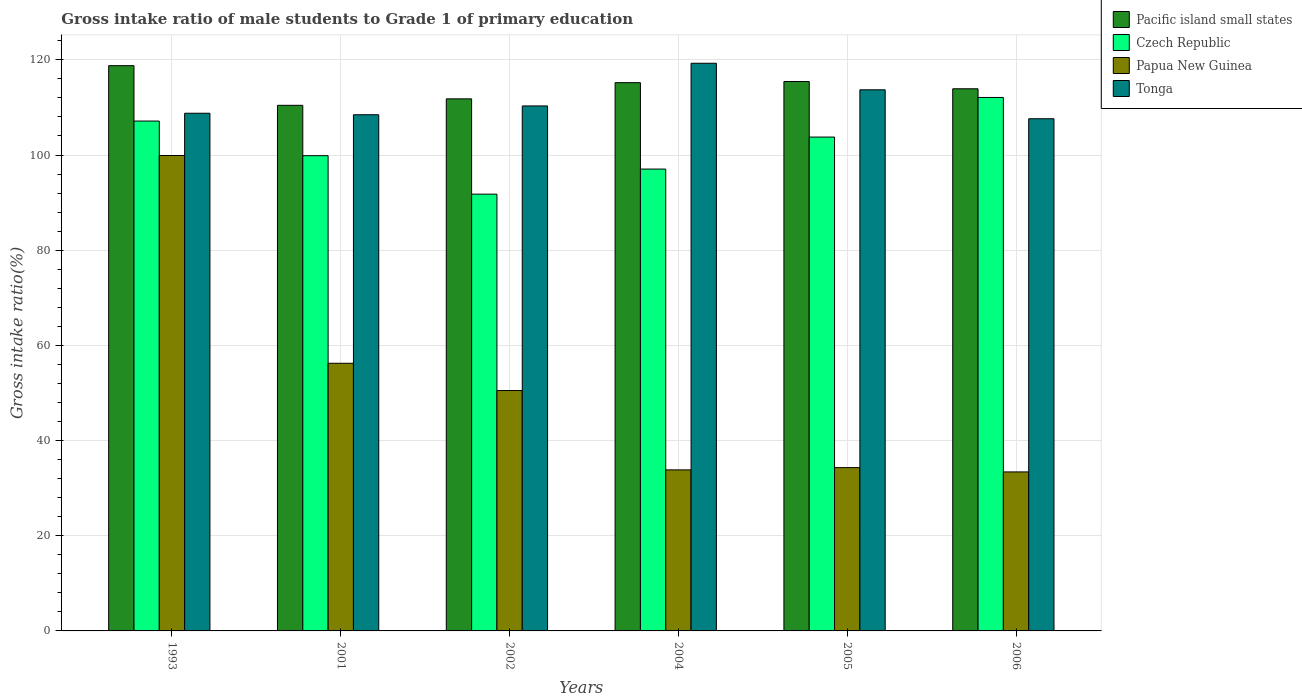Are the number of bars on each tick of the X-axis equal?
Provide a succinct answer. Yes. How many bars are there on the 6th tick from the left?
Provide a short and direct response. 4. How many bars are there on the 6th tick from the right?
Your answer should be compact. 4. In how many cases, is the number of bars for a given year not equal to the number of legend labels?
Provide a short and direct response. 0. What is the gross intake ratio in Papua New Guinea in 2004?
Give a very brief answer. 33.84. Across all years, what is the maximum gross intake ratio in Pacific island small states?
Provide a succinct answer. 118.78. Across all years, what is the minimum gross intake ratio in Pacific island small states?
Offer a terse response. 110.45. In which year was the gross intake ratio in Papua New Guinea maximum?
Your answer should be very brief. 1993. What is the total gross intake ratio in Pacific island small states in the graph?
Offer a terse response. 685.62. What is the difference between the gross intake ratio in Czech Republic in 1993 and that in 2006?
Offer a terse response. -4.96. What is the difference between the gross intake ratio in Pacific island small states in 1993 and the gross intake ratio in Tonga in 2002?
Your answer should be compact. 8.47. What is the average gross intake ratio in Czech Republic per year?
Provide a succinct answer. 101.95. In the year 1993, what is the difference between the gross intake ratio in Pacific island small states and gross intake ratio in Papua New Guinea?
Provide a succinct answer. 18.88. In how many years, is the gross intake ratio in Czech Republic greater than 56 %?
Provide a succinct answer. 6. What is the ratio of the gross intake ratio in Tonga in 1993 to that in 2005?
Offer a very short reply. 0.96. Is the difference between the gross intake ratio in Pacific island small states in 2004 and 2005 greater than the difference between the gross intake ratio in Papua New Guinea in 2004 and 2005?
Make the answer very short. Yes. What is the difference between the highest and the second highest gross intake ratio in Czech Republic?
Offer a terse response. 4.96. What is the difference between the highest and the lowest gross intake ratio in Tonga?
Your answer should be compact. 11.66. In how many years, is the gross intake ratio in Papua New Guinea greater than the average gross intake ratio in Papua New Guinea taken over all years?
Your response must be concise. 2. Is the sum of the gross intake ratio in Tonga in 1993 and 2001 greater than the maximum gross intake ratio in Pacific island small states across all years?
Keep it short and to the point. Yes. What does the 4th bar from the left in 2005 represents?
Keep it short and to the point. Tonga. What does the 2nd bar from the right in 1993 represents?
Keep it short and to the point. Papua New Guinea. How many bars are there?
Make the answer very short. 24. What is the difference between two consecutive major ticks on the Y-axis?
Offer a very short reply. 20. Does the graph contain any zero values?
Your response must be concise. No. How many legend labels are there?
Your answer should be compact. 4. What is the title of the graph?
Offer a very short reply. Gross intake ratio of male students to Grade 1 of primary education. Does "Colombia" appear as one of the legend labels in the graph?
Offer a terse response. No. What is the label or title of the Y-axis?
Your answer should be compact. Gross intake ratio(%). What is the Gross intake ratio(%) of Pacific island small states in 1993?
Give a very brief answer. 118.78. What is the Gross intake ratio(%) of Czech Republic in 1993?
Provide a succinct answer. 107.14. What is the Gross intake ratio(%) in Papua New Guinea in 1993?
Your response must be concise. 99.9. What is the Gross intake ratio(%) of Tonga in 1993?
Make the answer very short. 108.78. What is the Gross intake ratio(%) in Pacific island small states in 2001?
Your answer should be compact. 110.45. What is the Gross intake ratio(%) in Czech Republic in 2001?
Keep it short and to the point. 99.86. What is the Gross intake ratio(%) of Papua New Guinea in 2001?
Offer a very short reply. 56.24. What is the Gross intake ratio(%) of Tonga in 2001?
Provide a short and direct response. 108.47. What is the Gross intake ratio(%) of Pacific island small states in 2002?
Provide a short and direct response. 111.81. What is the Gross intake ratio(%) of Czech Republic in 2002?
Your answer should be very brief. 91.78. What is the Gross intake ratio(%) in Papua New Guinea in 2002?
Your response must be concise. 50.51. What is the Gross intake ratio(%) in Tonga in 2002?
Offer a terse response. 110.31. What is the Gross intake ratio(%) in Pacific island small states in 2004?
Make the answer very short. 115.21. What is the Gross intake ratio(%) in Czech Republic in 2004?
Provide a succinct answer. 97.05. What is the Gross intake ratio(%) in Papua New Guinea in 2004?
Your answer should be very brief. 33.84. What is the Gross intake ratio(%) in Tonga in 2004?
Keep it short and to the point. 119.29. What is the Gross intake ratio(%) in Pacific island small states in 2005?
Your response must be concise. 115.45. What is the Gross intake ratio(%) of Czech Republic in 2005?
Provide a succinct answer. 103.78. What is the Gross intake ratio(%) of Papua New Guinea in 2005?
Keep it short and to the point. 34.31. What is the Gross intake ratio(%) of Tonga in 2005?
Your answer should be compact. 113.71. What is the Gross intake ratio(%) in Pacific island small states in 2006?
Keep it short and to the point. 113.92. What is the Gross intake ratio(%) of Czech Republic in 2006?
Ensure brevity in your answer.  112.1. What is the Gross intake ratio(%) in Papua New Guinea in 2006?
Keep it short and to the point. 33.41. What is the Gross intake ratio(%) of Tonga in 2006?
Offer a terse response. 107.62. Across all years, what is the maximum Gross intake ratio(%) in Pacific island small states?
Provide a short and direct response. 118.78. Across all years, what is the maximum Gross intake ratio(%) of Czech Republic?
Your answer should be very brief. 112.1. Across all years, what is the maximum Gross intake ratio(%) in Papua New Guinea?
Give a very brief answer. 99.9. Across all years, what is the maximum Gross intake ratio(%) of Tonga?
Make the answer very short. 119.29. Across all years, what is the minimum Gross intake ratio(%) of Pacific island small states?
Your response must be concise. 110.45. Across all years, what is the minimum Gross intake ratio(%) in Czech Republic?
Offer a very short reply. 91.78. Across all years, what is the minimum Gross intake ratio(%) of Papua New Guinea?
Keep it short and to the point. 33.41. Across all years, what is the minimum Gross intake ratio(%) in Tonga?
Your answer should be compact. 107.62. What is the total Gross intake ratio(%) of Pacific island small states in the graph?
Give a very brief answer. 685.62. What is the total Gross intake ratio(%) of Czech Republic in the graph?
Keep it short and to the point. 611.71. What is the total Gross intake ratio(%) in Papua New Guinea in the graph?
Offer a terse response. 308.23. What is the total Gross intake ratio(%) in Tonga in the graph?
Make the answer very short. 668.18. What is the difference between the Gross intake ratio(%) of Pacific island small states in 1993 and that in 2001?
Offer a terse response. 8.34. What is the difference between the Gross intake ratio(%) in Czech Republic in 1993 and that in 2001?
Your response must be concise. 7.28. What is the difference between the Gross intake ratio(%) of Papua New Guinea in 1993 and that in 2001?
Provide a short and direct response. 43.66. What is the difference between the Gross intake ratio(%) of Tonga in 1993 and that in 2001?
Provide a succinct answer. 0.32. What is the difference between the Gross intake ratio(%) in Pacific island small states in 1993 and that in 2002?
Your response must be concise. 6.98. What is the difference between the Gross intake ratio(%) of Czech Republic in 1993 and that in 2002?
Make the answer very short. 15.36. What is the difference between the Gross intake ratio(%) in Papua New Guinea in 1993 and that in 2002?
Make the answer very short. 49.39. What is the difference between the Gross intake ratio(%) of Tonga in 1993 and that in 2002?
Offer a very short reply. -1.53. What is the difference between the Gross intake ratio(%) of Pacific island small states in 1993 and that in 2004?
Provide a succinct answer. 3.57. What is the difference between the Gross intake ratio(%) in Czech Republic in 1993 and that in 2004?
Your response must be concise. 10.09. What is the difference between the Gross intake ratio(%) of Papua New Guinea in 1993 and that in 2004?
Your answer should be very brief. 66.06. What is the difference between the Gross intake ratio(%) in Tonga in 1993 and that in 2004?
Keep it short and to the point. -10.5. What is the difference between the Gross intake ratio(%) in Pacific island small states in 1993 and that in 2005?
Offer a terse response. 3.33. What is the difference between the Gross intake ratio(%) in Czech Republic in 1993 and that in 2005?
Ensure brevity in your answer.  3.36. What is the difference between the Gross intake ratio(%) in Papua New Guinea in 1993 and that in 2005?
Give a very brief answer. 65.59. What is the difference between the Gross intake ratio(%) in Tonga in 1993 and that in 2005?
Give a very brief answer. -4.93. What is the difference between the Gross intake ratio(%) of Pacific island small states in 1993 and that in 2006?
Offer a terse response. 4.86. What is the difference between the Gross intake ratio(%) of Czech Republic in 1993 and that in 2006?
Keep it short and to the point. -4.96. What is the difference between the Gross intake ratio(%) in Papua New Guinea in 1993 and that in 2006?
Your answer should be compact. 66.49. What is the difference between the Gross intake ratio(%) in Tonga in 1993 and that in 2006?
Offer a terse response. 1.16. What is the difference between the Gross intake ratio(%) of Pacific island small states in 2001 and that in 2002?
Your response must be concise. -1.36. What is the difference between the Gross intake ratio(%) in Czech Republic in 2001 and that in 2002?
Your answer should be compact. 8.08. What is the difference between the Gross intake ratio(%) in Papua New Guinea in 2001 and that in 2002?
Offer a terse response. 5.73. What is the difference between the Gross intake ratio(%) in Tonga in 2001 and that in 2002?
Make the answer very short. -1.85. What is the difference between the Gross intake ratio(%) of Pacific island small states in 2001 and that in 2004?
Provide a succinct answer. -4.76. What is the difference between the Gross intake ratio(%) of Czech Republic in 2001 and that in 2004?
Offer a terse response. 2.81. What is the difference between the Gross intake ratio(%) of Papua New Guinea in 2001 and that in 2004?
Ensure brevity in your answer.  22.4. What is the difference between the Gross intake ratio(%) of Tonga in 2001 and that in 2004?
Make the answer very short. -10.82. What is the difference between the Gross intake ratio(%) of Pacific island small states in 2001 and that in 2005?
Provide a short and direct response. -5.01. What is the difference between the Gross intake ratio(%) in Czech Republic in 2001 and that in 2005?
Your response must be concise. -3.91. What is the difference between the Gross intake ratio(%) of Papua New Guinea in 2001 and that in 2005?
Offer a very short reply. 21.93. What is the difference between the Gross intake ratio(%) in Tonga in 2001 and that in 2005?
Give a very brief answer. -5.24. What is the difference between the Gross intake ratio(%) of Pacific island small states in 2001 and that in 2006?
Ensure brevity in your answer.  -3.48. What is the difference between the Gross intake ratio(%) of Czech Republic in 2001 and that in 2006?
Provide a succinct answer. -12.24. What is the difference between the Gross intake ratio(%) in Papua New Guinea in 2001 and that in 2006?
Make the answer very short. 22.83. What is the difference between the Gross intake ratio(%) in Tonga in 2001 and that in 2006?
Your answer should be compact. 0.84. What is the difference between the Gross intake ratio(%) in Pacific island small states in 2002 and that in 2004?
Offer a very short reply. -3.4. What is the difference between the Gross intake ratio(%) in Czech Republic in 2002 and that in 2004?
Your answer should be compact. -5.27. What is the difference between the Gross intake ratio(%) in Papua New Guinea in 2002 and that in 2004?
Keep it short and to the point. 16.67. What is the difference between the Gross intake ratio(%) of Tonga in 2002 and that in 2004?
Make the answer very short. -8.97. What is the difference between the Gross intake ratio(%) of Pacific island small states in 2002 and that in 2005?
Offer a very short reply. -3.65. What is the difference between the Gross intake ratio(%) in Czech Republic in 2002 and that in 2005?
Provide a short and direct response. -12. What is the difference between the Gross intake ratio(%) in Papua New Guinea in 2002 and that in 2005?
Keep it short and to the point. 16.2. What is the difference between the Gross intake ratio(%) in Tonga in 2002 and that in 2005?
Your response must be concise. -3.39. What is the difference between the Gross intake ratio(%) in Pacific island small states in 2002 and that in 2006?
Your answer should be compact. -2.12. What is the difference between the Gross intake ratio(%) in Czech Republic in 2002 and that in 2006?
Give a very brief answer. -20.32. What is the difference between the Gross intake ratio(%) of Papua New Guinea in 2002 and that in 2006?
Make the answer very short. 17.1. What is the difference between the Gross intake ratio(%) of Tonga in 2002 and that in 2006?
Your answer should be very brief. 2.69. What is the difference between the Gross intake ratio(%) of Pacific island small states in 2004 and that in 2005?
Keep it short and to the point. -0.24. What is the difference between the Gross intake ratio(%) in Czech Republic in 2004 and that in 2005?
Your answer should be compact. -6.73. What is the difference between the Gross intake ratio(%) of Papua New Guinea in 2004 and that in 2005?
Ensure brevity in your answer.  -0.47. What is the difference between the Gross intake ratio(%) of Tonga in 2004 and that in 2005?
Your response must be concise. 5.58. What is the difference between the Gross intake ratio(%) of Pacific island small states in 2004 and that in 2006?
Make the answer very short. 1.29. What is the difference between the Gross intake ratio(%) in Czech Republic in 2004 and that in 2006?
Ensure brevity in your answer.  -15.05. What is the difference between the Gross intake ratio(%) in Papua New Guinea in 2004 and that in 2006?
Keep it short and to the point. 0.43. What is the difference between the Gross intake ratio(%) of Tonga in 2004 and that in 2006?
Make the answer very short. 11.66. What is the difference between the Gross intake ratio(%) of Pacific island small states in 2005 and that in 2006?
Your response must be concise. 1.53. What is the difference between the Gross intake ratio(%) in Czech Republic in 2005 and that in 2006?
Provide a short and direct response. -8.32. What is the difference between the Gross intake ratio(%) of Papua New Guinea in 2005 and that in 2006?
Your response must be concise. 0.9. What is the difference between the Gross intake ratio(%) of Tonga in 2005 and that in 2006?
Provide a succinct answer. 6.08. What is the difference between the Gross intake ratio(%) of Pacific island small states in 1993 and the Gross intake ratio(%) of Czech Republic in 2001?
Offer a terse response. 18.92. What is the difference between the Gross intake ratio(%) in Pacific island small states in 1993 and the Gross intake ratio(%) in Papua New Guinea in 2001?
Keep it short and to the point. 62.54. What is the difference between the Gross intake ratio(%) of Pacific island small states in 1993 and the Gross intake ratio(%) of Tonga in 2001?
Ensure brevity in your answer.  10.32. What is the difference between the Gross intake ratio(%) in Czech Republic in 1993 and the Gross intake ratio(%) in Papua New Guinea in 2001?
Give a very brief answer. 50.9. What is the difference between the Gross intake ratio(%) in Czech Republic in 1993 and the Gross intake ratio(%) in Tonga in 2001?
Offer a terse response. -1.33. What is the difference between the Gross intake ratio(%) of Papua New Guinea in 1993 and the Gross intake ratio(%) of Tonga in 2001?
Your answer should be very brief. -8.56. What is the difference between the Gross intake ratio(%) in Pacific island small states in 1993 and the Gross intake ratio(%) in Czech Republic in 2002?
Provide a short and direct response. 27. What is the difference between the Gross intake ratio(%) of Pacific island small states in 1993 and the Gross intake ratio(%) of Papua New Guinea in 2002?
Your answer should be compact. 68.27. What is the difference between the Gross intake ratio(%) of Pacific island small states in 1993 and the Gross intake ratio(%) of Tonga in 2002?
Your answer should be very brief. 8.47. What is the difference between the Gross intake ratio(%) in Czech Republic in 1993 and the Gross intake ratio(%) in Papua New Guinea in 2002?
Offer a terse response. 56.63. What is the difference between the Gross intake ratio(%) in Czech Republic in 1993 and the Gross intake ratio(%) in Tonga in 2002?
Offer a terse response. -3.18. What is the difference between the Gross intake ratio(%) of Papua New Guinea in 1993 and the Gross intake ratio(%) of Tonga in 2002?
Offer a very short reply. -10.41. What is the difference between the Gross intake ratio(%) in Pacific island small states in 1993 and the Gross intake ratio(%) in Czech Republic in 2004?
Ensure brevity in your answer.  21.73. What is the difference between the Gross intake ratio(%) in Pacific island small states in 1993 and the Gross intake ratio(%) in Papua New Guinea in 2004?
Give a very brief answer. 84.94. What is the difference between the Gross intake ratio(%) of Pacific island small states in 1993 and the Gross intake ratio(%) of Tonga in 2004?
Offer a terse response. -0.5. What is the difference between the Gross intake ratio(%) in Czech Republic in 1993 and the Gross intake ratio(%) in Papua New Guinea in 2004?
Give a very brief answer. 73.3. What is the difference between the Gross intake ratio(%) of Czech Republic in 1993 and the Gross intake ratio(%) of Tonga in 2004?
Your answer should be very brief. -12.15. What is the difference between the Gross intake ratio(%) of Papua New Guinea in 1993 and the Gross intake ratio(%) of Tonga in 2004?
Make the answer very short. -19.38. What is the difference between the Gross intake ratio(%) of Pacific island small states in 1993 and the Gross intake ratio(%) of Czech Republic in 2005?
Keep it short and to the point. 15. What is the difference between the Gross intake ratio(%) in Pacific island small states in 1993 and the Gross intake ratio(%) in Papua New Guinea in 2005?
Keep it short and to the point. 84.47. What is the difference between the Gross intake ratio(%) in Pacific island small states in 1993 and the Gross intake ratio(%) in Tonga in 2005?
Your response must be concise. 5.07. What is the difference between the Gross intake ratio(%) in Czech Republic in 1993 and the Gross intake ratio(%) in Papua New Guinea in 2005?
Your answer should be very brief. 72.82. What is the difference between the Gross intake ratio(%) of Czech Republic in 1993 and the Gross intake ratio(%) of Tonga in 2005?
Ensure brevity in your answer.  -6.57. What is the difference between the Gross intake ratio(%) in Papua New Guinea in 1993 and the Gross intake ratio(%) in Tonga in 2005?
Offer a terse response. -13.8. What is the difference between the Gross intake ratio(%) in Pacific island small states in 1993 and the Gross intake ratio(%) in Czech Republic in 2006?
Give a very brief answer. 6.68. What is the difference between the Gross intake ratio(%) in Pacific island small states in 1993 and the Gross intake ratio(%) in Papua New Guinea in 2006?
Keep it short and to the point. 85.37. What is the difference between the Gross intake ratio(%) of Pacific island small states in 1993 and the Gross intake ratio(%) of Tonga in 2006?
Offer a very short reply. 11.16. What is the difference between the Gross intake ratio(%) in Czech Republic in 1993 and the Gross intake ratio(%) in Papua New Guinea in 2006?
Your answer should be compact. 73.73. What is the difference between the Gross intake ratio(%) of Czech Republic in 1993 and the Gross intake ratio(%) of Tonga in 2006?
Offer a terse response. -0.49. What is the difference between the Gross intake ratio(%) in Papua New Guinea in 1993 and the Gross intake ratio(%) in Tonga in 2006?
Provide a succinct answer. -7.72. What is the difference between the Gross intake ratio(%) of Pacific island small states in 2001 and the Gross intake ratio(%) of Czech Republic in 2002?
Keep it short and to the point. 18.67. What is the difference between the Gross intake ratio(%) in Pacific island small states in 2001 and the Gross intake ratio(%) in Papua New Guinea in 2002?
Offer a terse response. 59.93. What is the difference between the Gross intake ratio(%) in Pacific island small states in 2001 and the Gross intake ratio(%) in Tonga in 2002?
Make the answer very short. 0.13. What is the difference between the Gross intake ratio(%) in Czech Republic in 2001 and the Gross intake ratio(%) in Papua New Guinea in 2002?
Provide a short and direct response. 49.35. What is the difference between the Gross intake ratio(%) in Czech Republic in 2001 and the Gross intake ratio(%) in Tonga in 2002?
Give a very brief answer. -10.45. What is the difference between the Gross intake ratio(%) of Papua New Guinea in 2001 and the Gross intake ratio(%) of Tonga in 2002?
Give a very brief answer. -54.07. What is the difference between the Gross intake ratio(%) in Pacific island small states in 2001 and the Gross intake ratio(%) in Czech Republic in 2004?
Provide a short and direct response. 13.39. What is the difference between the Gross intake ratio(%) in Pacific island small states in 2001 and the Gross intake ratio(%) in Papua New Guinea in 2004?
Your answer should be very brief. 76.61. What is the difference between the Gross intake ratio(%) in Pacific island small states in 2001 and the Gross intake ratio(%) in Tonga in 2004?
Offer a very short reply. -8.84. What is the difference between the Gross intake ratio(%) in Czech Republic in 2001 and the Gross intake ratio(%) in Papua New Guinea in 2004?
Make the answer very short. 66.02. What is the difference between the Gross intake ratio(%) in Czech Republic in 2001 and the Gross intake ratio(%) in Tonga in 2004?
Make the answer very short. -19.42. What is the difference between the Gross intake ratio(%) of Papua New Guinea in 2001 and the Gross intake ratio(%) of Tonga in 2004?
Ensure brevity in your answer.  -63.04. What is the difference between the Gross intake ratio(%) in Pacific island small states in 2001 and the Gross intake ratio(%) in Czech Republic in 2005?
Offer a very short reply. 6.67. What is the difference between the Gross intake ratio(%) of Pacific island small states in 2001 and the Gross intake ratio(%) of Papua New Guinea in 2005?
Provide a short and direct response. 76.13. What is the difference between the Gross intake ratio(%) in Pacific island small states in 2001 and the Gross intake ratio(%) in Tonga in 2005?
Make the answer very short. -3.26. What is the difference between the Gross intake ratio(%) of Czech Republic in 2001 and the Gross intake ratio(%) of Papua New Guinea in 2005?
Provide a short and direct response. 65.55. What is the difference between the Gross intake ratio(%) of Czech Republic in 2001 and the Gross intake ratio(%) of Tonga in 2005?
Your answer should be compact. -13.84. What is the difference between the Gross intake ratio(%) of Papua New Guinea in 2001 and the Gross intake ratio(%) of Tonga in 2005?
Your response must be concise. -57.46. What is the difference between the Gross intake ratio(%) in Pacific island small states in 2001 and the Gross intake ratio(%) in Czech Republic in 2006?
Your answer should be very brief. -1.65. What is the difference between the Gross intake ratio(%) in Pacific island small states in 2001 and the Gross intake ratio(%) in Papua New Guinea in 2006?
Provide a short and direct response. 77.03. What is the difference between the Gross intake ratio(%) of Pacific island small states in 2001 and the Gross intake ratio(%) of Tonga in 2006?
Your answer should be very brief. 2.82. What is the difference between the Gross intake ratio(%) in Czech Republic in 2001 and the Gross intake ratio(%) in Papua New Guinea in 2006?
Give a very brief answer. 66.45. What is the difference between the Gross intake ratio(%) in Czech Republic in 2001 and the Gross intake ratio(%) in Tonga in 2006?
Provide a short and direct response. -7.76. What is the difference between the Gross intake ratio(%) of Papua New Guinea in 2001 and the Gross intake ratio(%) of Tonga in 2006?
Provide a succinct answer. -51.38. What is the difference between the Gross intake ratio(%) of Pacific island small states in 2002 and the Gross intake ratio(%) of Czech Republic in 2004?
Keep it short and to the point. 14.75. What is the difference between the Gross intake ratio(%) in Pacific island small states in 2002 and the Gross intake ratio(%) in Papua New Guinea in 2004?
Ensure brevity in your answer.  77.97. What is the difference between the Gross intake ratio(%) of Pacific island small states in 2002 and the Gross intake ratio(%) of Tonga in 2004?
Give a very brief answer. -7.48. What is the difference between the Gross intake ratio(%) of Czech Republic in 2002 and the Gross intake ratio(%) of Papua New Guinea in 2004?
Make the answer very short. 57.94. What is the difference between the Gross intake ratio(%) in Czech Republic in 2002 and the Gross intake ratio(%) in Tonga in 2004?
Keep it short and to the point. -27.51. What is the difference between the Gross intake ratio(%) of Papua New Guinea in 2002 and the Gross intake ratio(%) of Tonga in 2004?
Make the answer very short. -68.77. What is the difference between the Gross intake ratio(%) of Pacific island small states in 2002 and the Gross intake ratio(%) of Czech Republic in 2005?
Provide a succinct answer. 8.03. What is the difference between the Gross intake ratio(%) in Pacific island small states in 2002 and the Gross intake ratio(%) in Papua New Guinea in 2005?
Your answer should be very brief. 77.49. What is the difference between the Gross intake ratio(%) in Pacific island small states in 2002 and the Gross intake ratio(%) in Tonga in 2005?
Provide a short and direct response. -1.9. What is the difference between the Gross intake ratio(%) of Czech Republic in 2002 and the Gross intake ratio(%) of Papua New Guinea in 2005?
Offer a very short reply. 57.46. What is the difference between the Gross intake ratio(%) in Czech Republic in 2002 and the Gross intake ratio(%) in Tonga in 2005?
Provide a succinct answer. -21.93. What is the difference between the Gross intake ratio(%) of Papua New Guinea in 2002 and the Gross intake ratio(%) of Tonga in 2005?
Give a very brief answer. -63.19. What is the difference between the Gross intake ratio(%) in Pacific island small states in 2002 and the Gross intake ratio(%) in Czech Republic in 2006?
Your response must be concise. -0.29. What is the difference between the Gross intake ratio(%) of Pacific island small states in 2002 and the Gross intake ratio(%) of Papua New Guinea in 2006?
Your answer should be compact. 78.39. What is the difference between the Gross intake ratio(%) of Pacific island small states in 2002 and the Gross intake ratio(%) of Tonga in 2006?
Keep it short and to the point. 4.18. What is the difference between the Gross intake ratio(%) of Czech Republic in 2002 and the Gross intake ratio(%) of Papua New Guinea in 2006?
Ensure brevity in your answer.  58.37. What is the difference between the Gross intake ratio(%) of Czech Republic in 2002 and the Gross intake ratio(%) of Tonga in 2006?
Offer a very short reply. -15.85. What is the difference between the Gross intake ratio(%) in Papua New Guinea in 2002 and the Gross intake ratio(%) in Tonga in 2006?
Provide a short and direct response. -57.11. What is the difference between the Gross intake ratio(%) in Pacific island small states in 2004 and the Gross intake ratio(%) in Czech Republic in 2005?
Offer a terse response. 11.43. What is the difference between the Gross intake ratio(%) in Pacific island small states in 2004 and the Gross intake ratio(%) in Papua New Guinea in 2005?
Your answer should be compact. 80.89. What is the difference between the Gross intake ratio(%) of Pacific island small states in 2004 and the Gross intake ratio(%) of Tonga in 2005?
Provide a succinct answer. 1.5. What is the difference between the Gross intake ratio(%) in Czech Republic in 2004 and the Gross intake ratio(%) in Papua New Guinea in 2005?
Provide a short and direct response. 62.74. What is the difference between the Gross intake ratio(%) in Czech Republic in 2004 and the Gross intake ratio(%) in Tonga in 2005?
Your answer should be very brief. -16.66. What is the difference between the Gross intake ratio(%) of Papua New Guinea in 2004 and the Gross intake ratio(%) of Tonga in 2005?
Your response must be concise. -79.87. What is the difference between the Gross intake ratio(%) of Pacific island small states in 2004 and the Gross intake ratio(%) of Czech Republic in 2006?
Your answer should be compact. 3.11. What is the difference between the Gross intake ratio(%) in Pacific island small states in 2004 and the Gross intake ratio(%) in Papua New Guinea in 2006?
Give a very brief answer. 81.8. What is the difference between the Gross intake ratio(%) in Pacific island small states in 2004 and the Gross intake ratio(%) in Tonga in 2006?
Provide a short and direct response. 7.58. What is the difference between the Gross intake ratio(%) of Czech Republic in 2004 and the Gross intake ratio(%) of Papua New Guinea in 2006?
Give a very brief answer. 63.64. What is the difference between the Gross intake ratio(%) in Czech Republic in 2004 and the Gross intake ratio(%) in Tonga in 2006?
Make the answer very short. -10.57. What is the difference between the Gross intake ratio(%) in Papua New Guinea in 2004 and the Gross intake ratio(%) in Tonga in 2006?
Offer a very short reply. -73.78. What is the difference between the Gross intake ratio(%) of Pacific island small states in 2005 and the Gross intake ratio(%) of Czech Republic in 2006?
Your response must be concise. 3.35. What is the difference between the Gross intake ratio(%) of Pacific island small states in 2005 and the Gross intake ratio(%) of Papua New Guinea in 2006?
Offer a terse response. 82.04. What is the difference between the Gross intake ratio(%) of Pacific island small states in 2005 and the Gross intake ratio(%) of Tonga in 2006?
Ensure brevity in your answer.  7.83. What is the difference between the Gross intake ratio(%) of Czech Republic in 2005 and the Gross intake ratio(%) of Papua New Guinea in 2006?
Ensure brevity in your answer.  70.36. What is the difference between the Gross intake ratio(%) of Czech Republic in 2005 and the Gross intake ratio(%) of Tonga in 2006?
Your answer should be very brief. -3.85. What is the difference between the Gross intake ratio(%) of Papua New Guinea in 2005 and the Gross intake ratio(%) of Tonga in 2006?
Give a very brief answer. -73.31. What is the average Gross intake ratio(%) of Pacific island small states per year?
Give a very brief answer. 114.27. What is the average Gross intake ratio(%) of Czech Republic per year?
Give a very brief answer. 101.95. What is the average Gross intake ratio(%) of Papua New Guinea per year?
Your answer should be compact. 51.37. What is the average Gross intake ratio(%) of Tonga per year?
Your answer should be very brief. 111.36. In the year 1993, what is the difference between the Gross intake ratio(%) in Pacific island small states and Gross intake ratio(%) in Czech Republic?
Your answer should be compact. 11.64. In the year 1993, what is the difference between the Gross intake ratio(%) in Pacific island small states and Gross intake ratio(%) in Papua New Guinea?
Keep it short and to the point. 18.88. In the year 1993, what is the difference between the Gross intake ratio(%) of Pacific island small states and Gross intake ratio(%) of Tonga?
Provide a short and direct response. 10. In the year 1993, what is the difference between the Gross intake ratio(%) of Czech Republic and Gross intake ratio(%) of Papua New Guinea?
Offer a terse response. 7.24. In the year 1993, what is the difference between the Gross intake ratio(%) of Czech Republic and Gross intake ratio(%) of Tonga?
Your answer should be very brief. -1.64. In the year 1993, what is the difference between the Gross intake ratio(%) of Papua New Guinea and Gross intake ratio(%) of Tonga?
Keep it short and to the point. -8.88. In the year 2001, what is the difference between the Gross intake ratio(%) in Pacific island small states and Gross intake ratio(%) in Czech Republic?
Your response must be concise. 10.58. In the year 2001, what is the difference between the Gross intake ratio(%) in Pacific island small states and Gross intake ratio(%) in Papua New Guinea?
Give a very brief answer. 54.2. In the year 2001, what is the difference between the Gross intake ratio(%) of Pacific island small states and Gross intake ratio(%) of Tonga?
Ensure brevity in your answer.  1.98. In the year 2001, what is the difference between the Gross intake ratio(%) in Czech Republic and Gross intake ratio(%) in Papua New Guinea?
Your answer should be very brief. 43.62. In the year 2001, what is the difference between the Gross intake ratio(%) in Czech Republic and Gross intake ratio(%) in Tonga?
Your response must be concise. -8.6. In the year 2001, what is the difference between the Gross intake ratio(%) of Papua New Guinea and Gross intake ratio(%) of Tonga?
Provide a succinct answer. -52.22. In the year 2002, what is the difference between the Gross intake ratio(%) in Pacific island small states and Gross intake ratio(%) in Czech Republic?
Ensure brevity in your answer.  20.03. In the year 2002, what is the difference between the Gross intake ratio(%) in Pacific island small states and Gross intake ratio(%) in Papua New Guinea?
Your answer should be very brief. 61.29. In the year 2002, what is the difference between the Gross intake ratio(%) of Pacific island small states and Gross intake ratio(%) of Tonga?
Give a very brief answer. 1.49. In the year 2002, what is the difference between the Gross intake ratio(%) of Czech Republic and Gross intake ratio(%) of Papua New Guinea?
Offer a terse response. 41.27. In the year 2002, what is the difference between the Gross intake ratio(%) in Czech Republic and Gross intake ratio(%) in Tonga?
Ensure brevity in your answer.  -18.54. In the year 2002, what is the difference between the Gross intake ratio(%) in Papua New Guinea and Gross intake ratio(%) in Tonga?
Offer a very short reply. -59.8. In the year 2004, what is the difference between the Gross intake ratio(%) of Pacific island small states and Gross intake ratio(%) of Czech Republic?
Provide a succinct answer. 18.16. In the year 2004, what is the difference between the Gross intake ratio(%) of Pacific island small states and Gross intake ratio(%) of Papua New Guinea?
Your answer should be compact. 81.37. In the year 2004, what is the difference between the Gross intake ratio(%) in Pacific island small states and Gross intake ratio(%) in Tonga?
Offer a terse response. -4.08. In the year 2004, what is the difference between the Gross intake ratio(%) in Czech Republic and Gross intake ratio(%) in Papua New Guinea?
Provide a succinct answer. 63.21. In the year 2004, what is the difference between the Gross intake ratio(%) of Czech Republic and Gross intake ratio(%) of Tonga?
Ensure brevity in your answer.  -22.23. In the year 2004, what is the difference between the Gross intake ratio(%) in Papua New Guinea and Gross intake ratio(%) in Tonga?
Keep it short and to the point. -85.44. In the year 2005, what is the difference between the Gross intake ratio(%) of Pacific island small states and Gross intake ratio(%) of Czech Republic?
Ensure brevity in your answer.  11.68. In the year 2005, what is the difference between the Gross intake ratio(%) of Pacific island small states and Gross intake ratio(%) of Papua New Guinea?
Provide a succinct answer. 81.14. In the year 2005, what is the difference between the Gross intake ratio(%) of Pacific island small states and Gross intake ratio(%) of Tonga?
Make the answer very short. 1.75. In the year 2005, what is the difference between the Gross intake ratio(%) in Czech Republic and Gross intake ratio(%) in Papua New Guinea?
Give a very brief answer. 69.46. In the year 2005, what is the difference between the Gross intake ratio(%) in Czech Republic and Gross intake ratio(%) in Tonga?
Offer a very short reply. -9.93. In the year 2005, what is the difference between the Gross intake ratio(%) in Papua New Guinea and Gross intake ratio(%) in Tonga?
Your answer should be compact. -79.39. In the year 2006, what is the difference between the Gross intake ratio(%) in Pacific island small states and Gross intake ratio(%) in Czech Republic?
Provide a short and direct response. 1.82. In the year 2006, what is the difference between the Gross intake ratio(%) in Pacific island small states and Gross intake ratio(%) in Papua New Guinea?
Ensure brevity in your answer.  80.51. In the year 2006, what is the difference between the Gross intake ratio(%) of Pacific island small states and Gross intake ratio(%) of Tonga?
Offer a terse response. 6.3. In the year 2006, what is the difference between the Gross intake ratio(%) of Czech Republic and Gross intake ratio(%) of Papua New Guinea?
Your answer should be very brief. 78.69. In the year 2006, what is the difference between the Gross intake ratio(%) in Czech Republic and Gross intake ratio(%) in Tonga?
Offer a terse response. 4.47. In the year 2006, what is the difference between the Gross intake ratio(%) of Papua New Guinea and Gross intake ratio(%) of Tonga?
Your response must be concise. -74.21. What is the ratio of the Gross intake ratio(%) in Pacific island small states in 1993 to that in 2001?
Ensure brevity in your answer.  1.08. What is the ratio of the Gross intake ratio(%) in Czech Republic in 1993 to that in 2001?
Keep it short and to the point. 1.07. What is the ratio of the Gross intake ratio(%) in Papua New Guinea in 1993 to that in 2001?
Your answer should be very brief. 1.78. What is the ratio of the Gross intake ratio(%) of Pacific island small states in 1993 to that in 2002?
Give a very brief answer. 1.06. What is the ratio of the Gross intake ratio(%) in Czech Republic in 1993 to that in 2002?
Provide a succinct answer. 1.17. What is the ratio of the Gross intake ratio(%) of Papua New Guinea in 1993 to that in 2002?
Give a very brief answer. 1.98. What is the ratio of the Gross intake ratio(%) in Tonga in 1993 to that in 2002?
Offer a very short reply. 0.99. What is the ratio of the Gross intake ratio(%) of Pacific island small states in 1993 to that in 2004?
Your response must be concise. 1.03. What is the ratio of the Gross intake ratio(%) of Czech Republic in 1993 to that in 2004?
Provide a succinct answer. 1.1. What is the ratio of the Gross intake ratio(%) in Papua New Guinea in 1993 to that in 2004?
Offer a terse response. 2.95. What is the ratio of the Gross intake ratio(%) of Tonga in 1993 to that in 2004?
Ensure brevity in your answer.  0.91. What is the ratio of the Gross intake ratio(%) in Pacific island small states in 1993 to that in 2005?
Your response must be concise. 1.03. What is the ratio of the Gross intake ratio(%) in Czech Republic in 1993 to that in 2005?
Make the answer very short. 1.03. What is the ratio of the Gross intake ratio(%) in Papua New Guinea in 1993 to that in 2005?
Provide a short and direct response. 2.91. What is the ratio of the Gross intake ratio(%) in Tonga in 1993 to that in 2005?
Provide a short and direct response. 0.96. What is the ratio of the Gross intake ratio(%) in Pacific island small states in 1993 to that in 2006?
Your answer should be compact. 1.04. What is the ratio of the Gross intake ratio(%) of Czech Republic in 1993 to that in 2006?
Provide a short and direct response. 0.96. What is the ratio of the Gross intake ratio(%) of Papua New Guinea in 1993 to that in 2006?
Offer a terse response. 2.99. What is the ratio of the Gross intake ratio(%) of Tonga in 1993 to that in 2006?
Your answer should be compact. 1.01. What is the ratio of the Gross intake ratio(%) in Pacific island small states in 2001 to that in 2002?
Offer a terse response. 0.99. What is the ratio of the Gross intake ratio(%) in Czech Republic in 2001 to that in 2002?
Your answer should be compact. 1.09. What is the ratio of the Gross intake ratio(%) in Papua New Guinea in 2001 to that in 2002?
Give a very brief answer. 1.11. What is the ratio of the Gross intake ratio(%) of Tonga in 2001 to that in 2002?
Provide a succinct answer. 0.98. What is the ratio of the Gross intake ratio(%) in Pacific island small states in 2001 to that in 2004?
Offer a terse response. 0.96. What is the ratio of the Gross intake ratio(%) of Papua New Guinea in 2001 to that in 2004?
Give a very brief answer. 1.66. What is the ratio of the Gross intake ratio(%) in Tonga in 2001 to that in 2004?
Give a very brief answer. 0.91. What is the ratio of the Gross intake ratio(%) in Pacific island small states in 2001 to that in 2005?
Give a very brief answer. 0.96. What is the ratio of the Gross intake ratio(%) in Czech Republic in 2001 to that in 2005?
Make the answer very short. 0.96. What is the ratio of the Gross intake ratio(%) in Papua New Guinea in 2001 to that in 2005?
Make the answer very short. 1.64. What is the ratio of the Gross intake ratio(%) in Tonga in 2001 to that in 2005?
Make the answer very short. 0.95. What is the ratio of the Gross intake ratio(%) of Pacific island small states in 2001 to that in 2006?
Give a very brief answer. 0.97. What is the ratio of the Gross intake ratio(%) of Czech Republic in 2001 to that in 2006?
Provide a short and direct response. 0.89. What is the ratio of the Gross intake ratio(%) of Papua New Guinea in 2001 to that in 2006?
Ensure brevity in your answer.  1.68. What is the ratio of the Gross intake ratio(%) in Pacific island small states in 2002 to that in 2004?
Make the answer very short. 0.97. What is the ratio of the Gross intake ratio(%) of Czech Republic in 2002 to that in 2004?
Give a very brief answer. 0.95. What is the ratio of the Gross intake ratio(%) in Papua New Guinea in 2002 to that in 2004?
Keep it short and to the point. 1.49. What is the ratio of the Gross intake ratio(%) in Tonga in 2002 to that in 2004?
Your answer should be compact. 0.92. What is the ratio of the Gross intake ratio(%) in Pacific island small states in 2002 to that in 2005?
Your answer should be very brief. 0.97. What is the ratio of the Gross intake ratio(%) in Czech Republic in 2002 to that in 2005?
Your answer should be very brief. 0.88. What is the ratio of the Gross intake ratio(%) of Papua New Guinea in 2002 to that in 2005?
Keep it short and to the point. 1.47. What is the ratio of the Gross intake ratio(%) of Tonga in 2002 to that in 2005?
Keep it short and to the point. 0.97. What is the ratio of the Gross intake ratio(%) of Pacific island small states in 2002 to that in 2006?
Keep it short and to the point. 0.98. What is the ratio of the Gross intake ratio(%) of Czech Republic in 2002 to that in 2006?
Give a very brief answer. 0.82. What is the ratio of the Gross intake ratio(%) of Papua New Guinea in 2002 to that in 2006?
Provide a succinct answer. 1.51. What is the ratio of the Gross intake ratio(%) in Tonga in 2002 to that in 2006?
Ensure brevity in your answer.  1.02. What is the ratio of the Gross intake ratio(%) in Pacific island small states in 2004 to that in 2005?
Provide a succinct answer. 1. What is the ratio of the Gross intake ratio(%) of Czech Republic in 2004 to that in 2005?
Your answer should be compact. 0.94. What is the ratio of the Gross intake ratio(%) of Papua New Guinea in 2004 to that in 2005?
Your response must be concise. 0.99. What is the ratio of the Gross intake ratio(%) in Tonga in 2004 to that in 2005?
Give a very brief answer. 1.05. What is the ratio of the Gross intake ratio(%) in Pacific island small states in 2004 to that in 2006?
Offer a terse response. 1.01. What is the ratio of the Gross intake ratio(%) of Czech Republic in 2004 to that in 2006?
Provide a succinct answer. 0.87. What is the ratio of the Gross intake ratio(%) in Papua New Guinea in 2004 to that in 2006?
Your response must be concise. 1.01. What is the ratio of the Gross intake ratio(%) in Tonga in 2004 to that in 2006?
Offer a very short reply. 1.11. What is the ratio of the Gross intake ratio(%) of Pacific island small states in 2005 to that in 2006?
Give a very brief answer. 1.01. What is the ratio of the Gross intake ratio(%) of Czech Republic in 2005 to that in 2006?
Give a very brief answer. 0.93. What is the ratio of the Gross intake ratio(%) in Tonga in 2005 to that in 2006?
Offer a very short reply. 1.06. What is the difference between the highest and the second highest Gross intake ratio(%) of Pacific island small states?
Provide a succinct answer. 3.33. What is the difference between the highest and the second highest Gross intake ratio(%) in Czech Republic?
Offer a terse response. 4.96. What is the difference between the highest and the second highest Gross intake ratio(%) of Papua New Guinea?
Keep it short and to the point. 43.66. What is the difference between the highest and the second highest Gross intake ratio(%) of Tonga?
Give a very brief answer. 5.58. What is the difference between the highest and the lowest Gross intake ratio(%) of Pacific island small states?
Make the answer very short. 8.34. What is the difference between the highest and the lowest Gross intake ratio(%) of Czech Republic?
Your response must be concise. 20.32. What is the difference between the highest and the lowest Gross intake ratio(%) of Papua New Guinea?
Your answer should be very brief. 66.49. What is the difference between the highest and the lowest Gross intake ratio(%) of Tonga?
Provide a short and direct response. 11.66. 